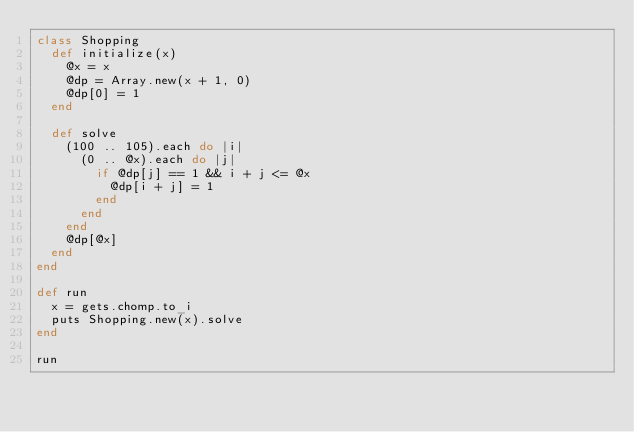<code> <loc_0><loc_0><loc_500><loc_500><_Ruby_>class Shopping
  def initialize(x)
    @x = x
    @dp = Array.new(x + 1, 0)
    @dp[0] = 1
  end

  def solve
    (100 .. 105).each do |i|
      (0 .. @x).each do |j|
        if @dp[j] == 1 && i + j <= @x
          @dp[i + j] = 1
        end
      end
    end
    @dp[@x]
  end
end

def run
  x = gets.chomp.to_i
  puts Shopping.new(x).solve
end

run
</code> 